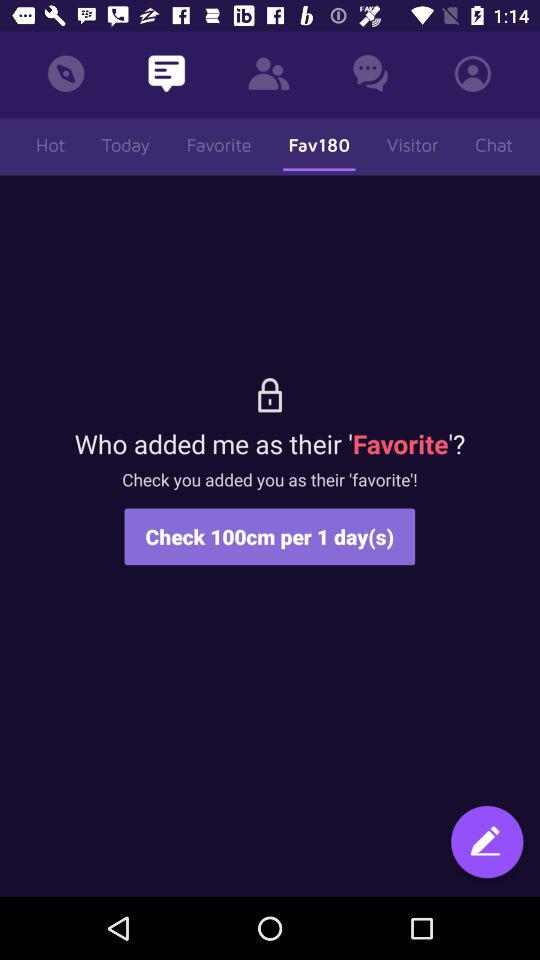How many days does it take to grow 100cm?
Answer the question using a single word or phrase. 1 day(s) 